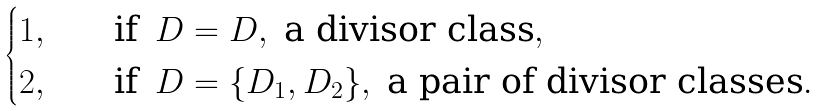Convert formula to latex. <formula><loc_0><loc_0><loc_500><loc_500>\begin{cases} 1 , \quad & \text {if} \, \ D = D , \ \text {a divisor class} , \\ 2 , \quad & \text {if} \, \ D = \{ D _ { 1 } , D _ { 2 } \} , \ \text {a pair of divisor classes} . \end{cases}</formula> 